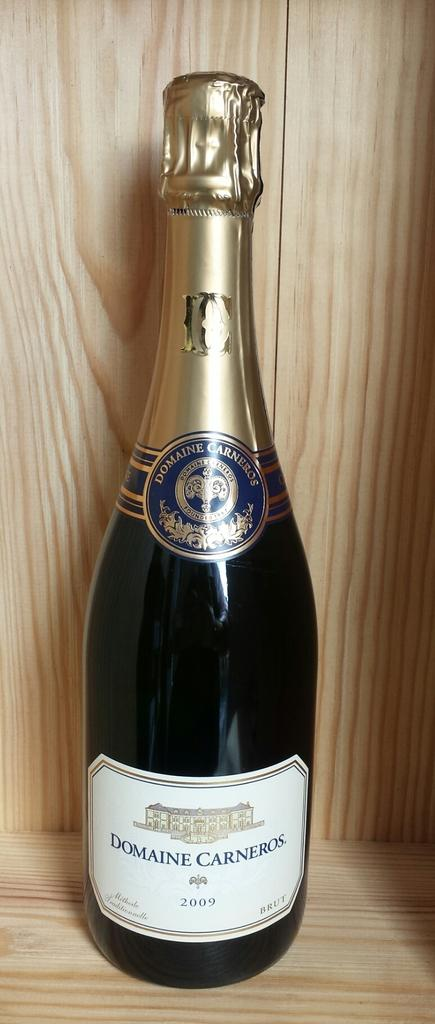<image>
Present a compact description of the photo's key features. On a shelf display sits a 2009 bottle of Domaine Carneros. 